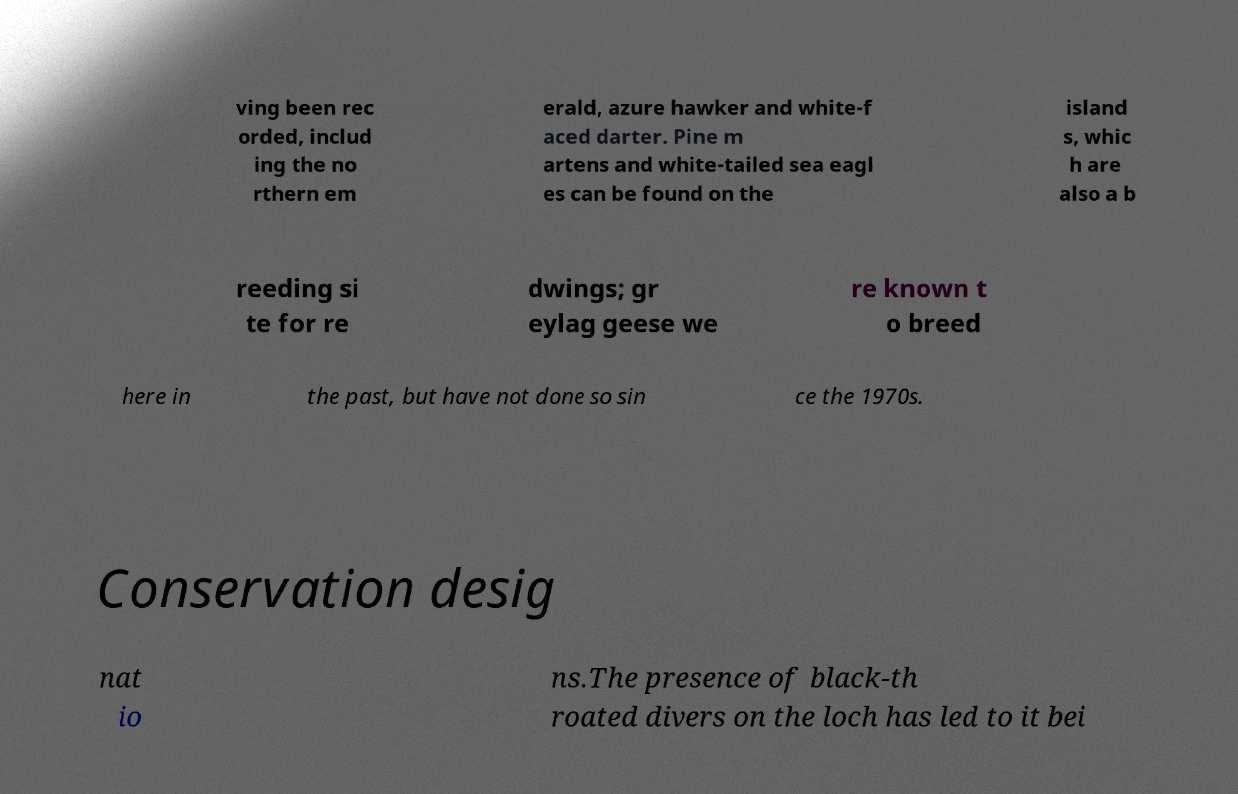Please identify and transcribe the text found in this image. ving been rec orded, includ ing the no rthern em erald, azure hawker and white-f aced darter. Pine m artens and white-tailed sea eagl es can be found on the island s, whic h are also a b reeding si te for re dwings; gr eylag geese we re known t o breed here in the past, but have not done so sin ce the 1970s. Conservation desig nat io ns.The presence of black-th roated divers on the loch has led to it bei 